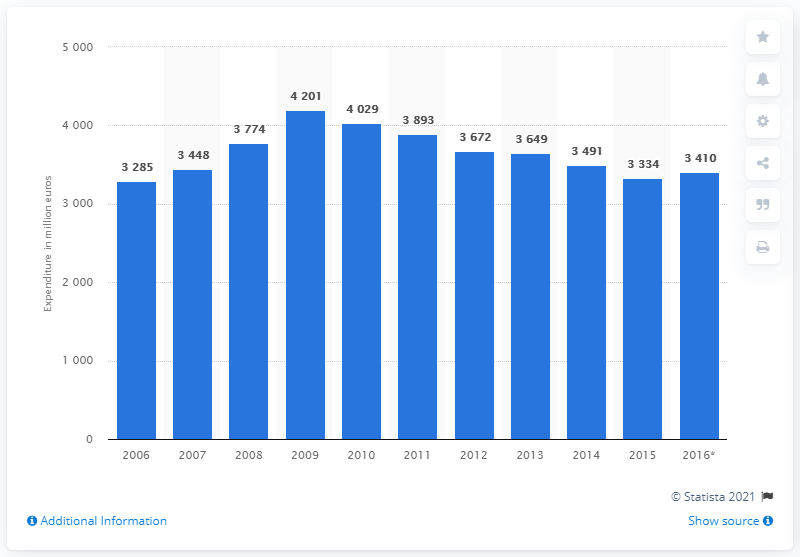Give some essential details in this illustration. The total expenditure on recreation and sport in the Netherlands in 2016 was 3,410... 